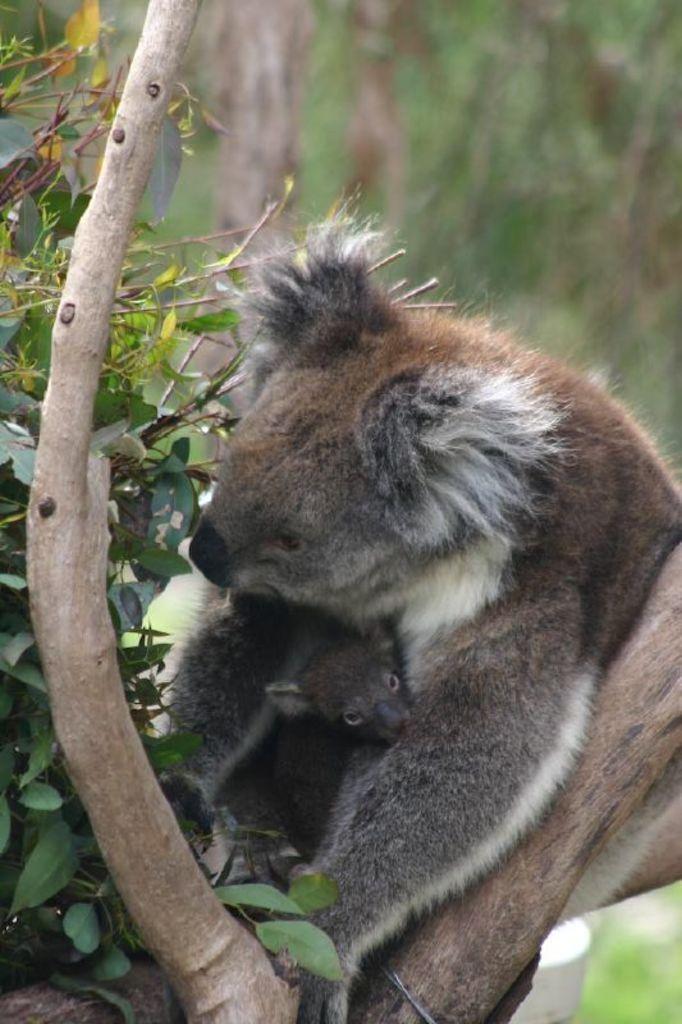In one or two sentences, can you explain what this image depicts? There is an animal on a tree. In the background it is blurred. 